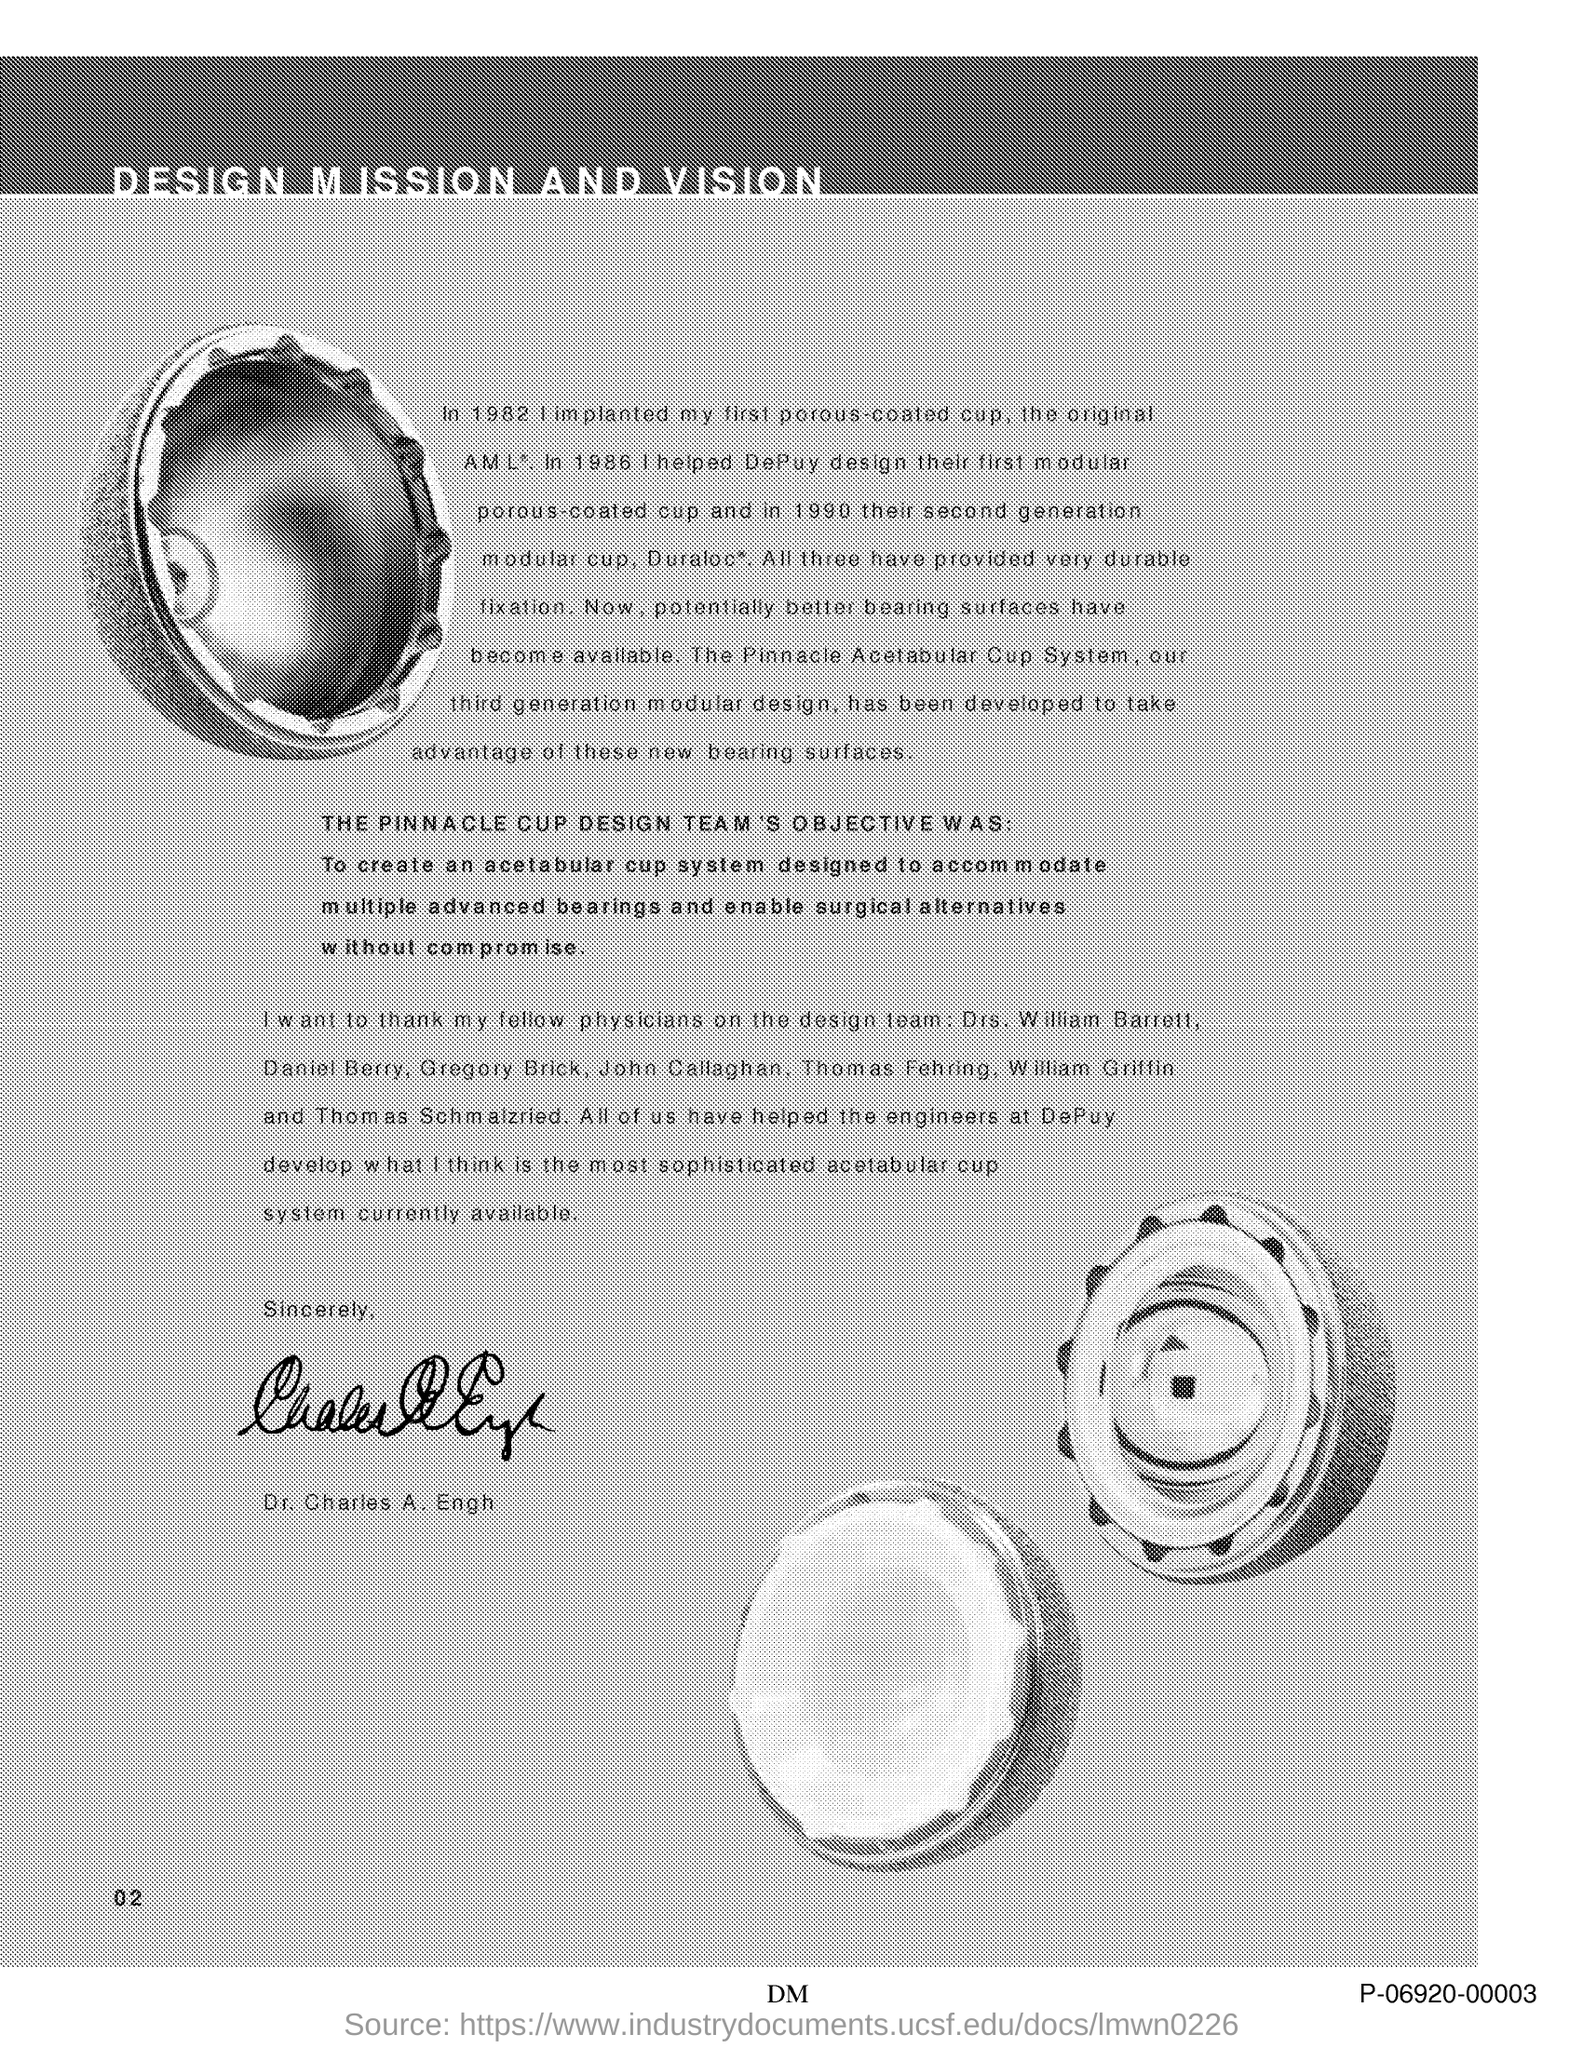What is the title of this document?
Your response must be concise. Design Mission And Vision. What is the page no mentioned in this document?
Provide a short and direct response. 2. Who has signed this document?
Keep it short and to the point. Dr. Charles A. Engh. 